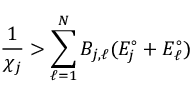<formula> <loc_0><loc_0><loc_500><loc_500>\frac { 1 } { \chi _ { j } } > \sum _ { \ell = 1 } ^ { N } B _ { j , \ell } ( E _ { j } ^ { \circ } + E _ { \ell } ^ { \circ } )</formula> 